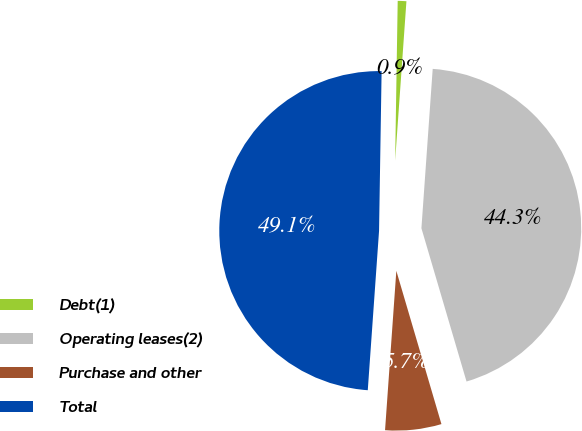Convert chart. <chart><loc_0><loc_0><loc_500><loc_500><pie_chart><fcel>Debt(1)<fcel>Operating leases(2)<fcel>Purchase and other<fcel>Total<nl><fcel>0.87%<fcel>44.32%<fcel>5.68%<fcel>49.13%<nl></chart> 